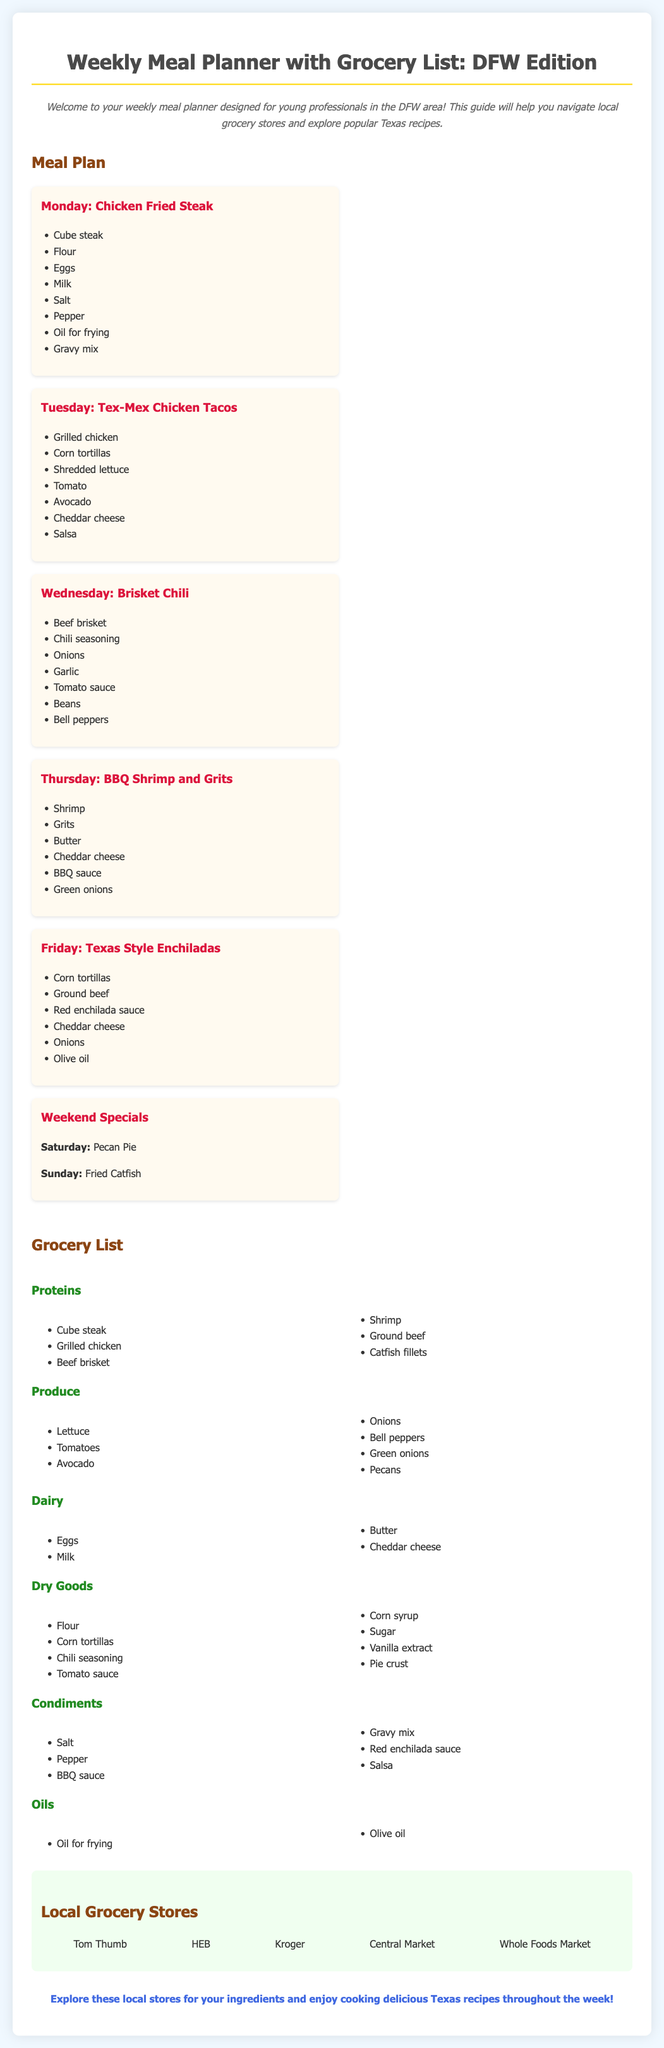What dish is planned for Monday? The document specifies "Chicken Fried Steak" as the dish for Monday.
Answer: Chicken Fried Steak Which grocery store is listed first? The first local grocery store mentioned in the document is Tom Thumb.
Answer: Tom Thumb How many main meals are listed in the meal plan? The meal plan contains five main meals from Monday to Friday plus weekend specials, totaling seven.
Answer: 7 What type of cheese is used in the BBQ Shrimp and Grits? The document states that Cheddar cheese is included in the ingredients for BBQ Shrimp and Grits.
Answer: Cheddar cheese What is one of the weekend specials? The document mentions "Pecan Pie" as one of the weekend specials.
Answer: Pecan Pie How many categories are in the grocery list? The grocery list has five categories: Proteins, Produce, Dairy, Dry Goods, and Condiments.
Answer: 5 Which recipe requires corn tortillas? The recipes for both "Tex-Mex Chicken Tacos" and "Texas Style Enchiladas" require corn tortillas.
Answer: Tex-Mex Chicken Tacos, Texas Style Enchiladas What is the primary type of cuisine featured in the meal planner? The document focuses on Tex-Mex and traditional Texas dishes as part of the meal planner.
Answer: Tex-Mex and traditional Texas dishes 